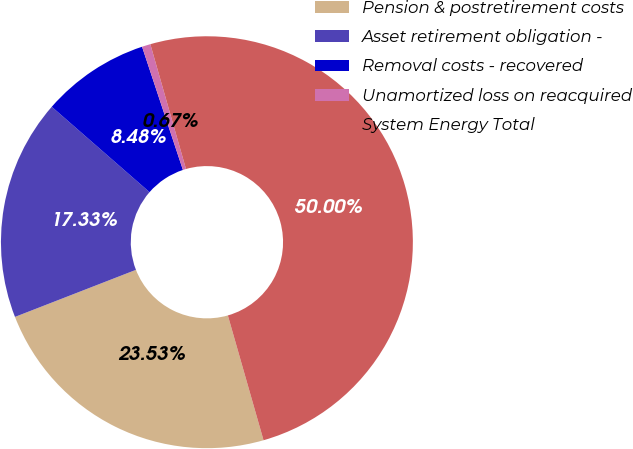Convert chart. <chart><loc_0><loc_0><loc_500><loc_500><pie_chart><fcel>Pension & postretirement costs<fcel>Asset retirement obligation -<fcel>Removal costs - recovered<fcel>Unamortized loss on reacquired<fcel>System Energy Total<nl><fcel>23.53%<fcel>17.33%<fcel>8.48%<fcel>0.67%<fcel>50.0%<nl></chart> 